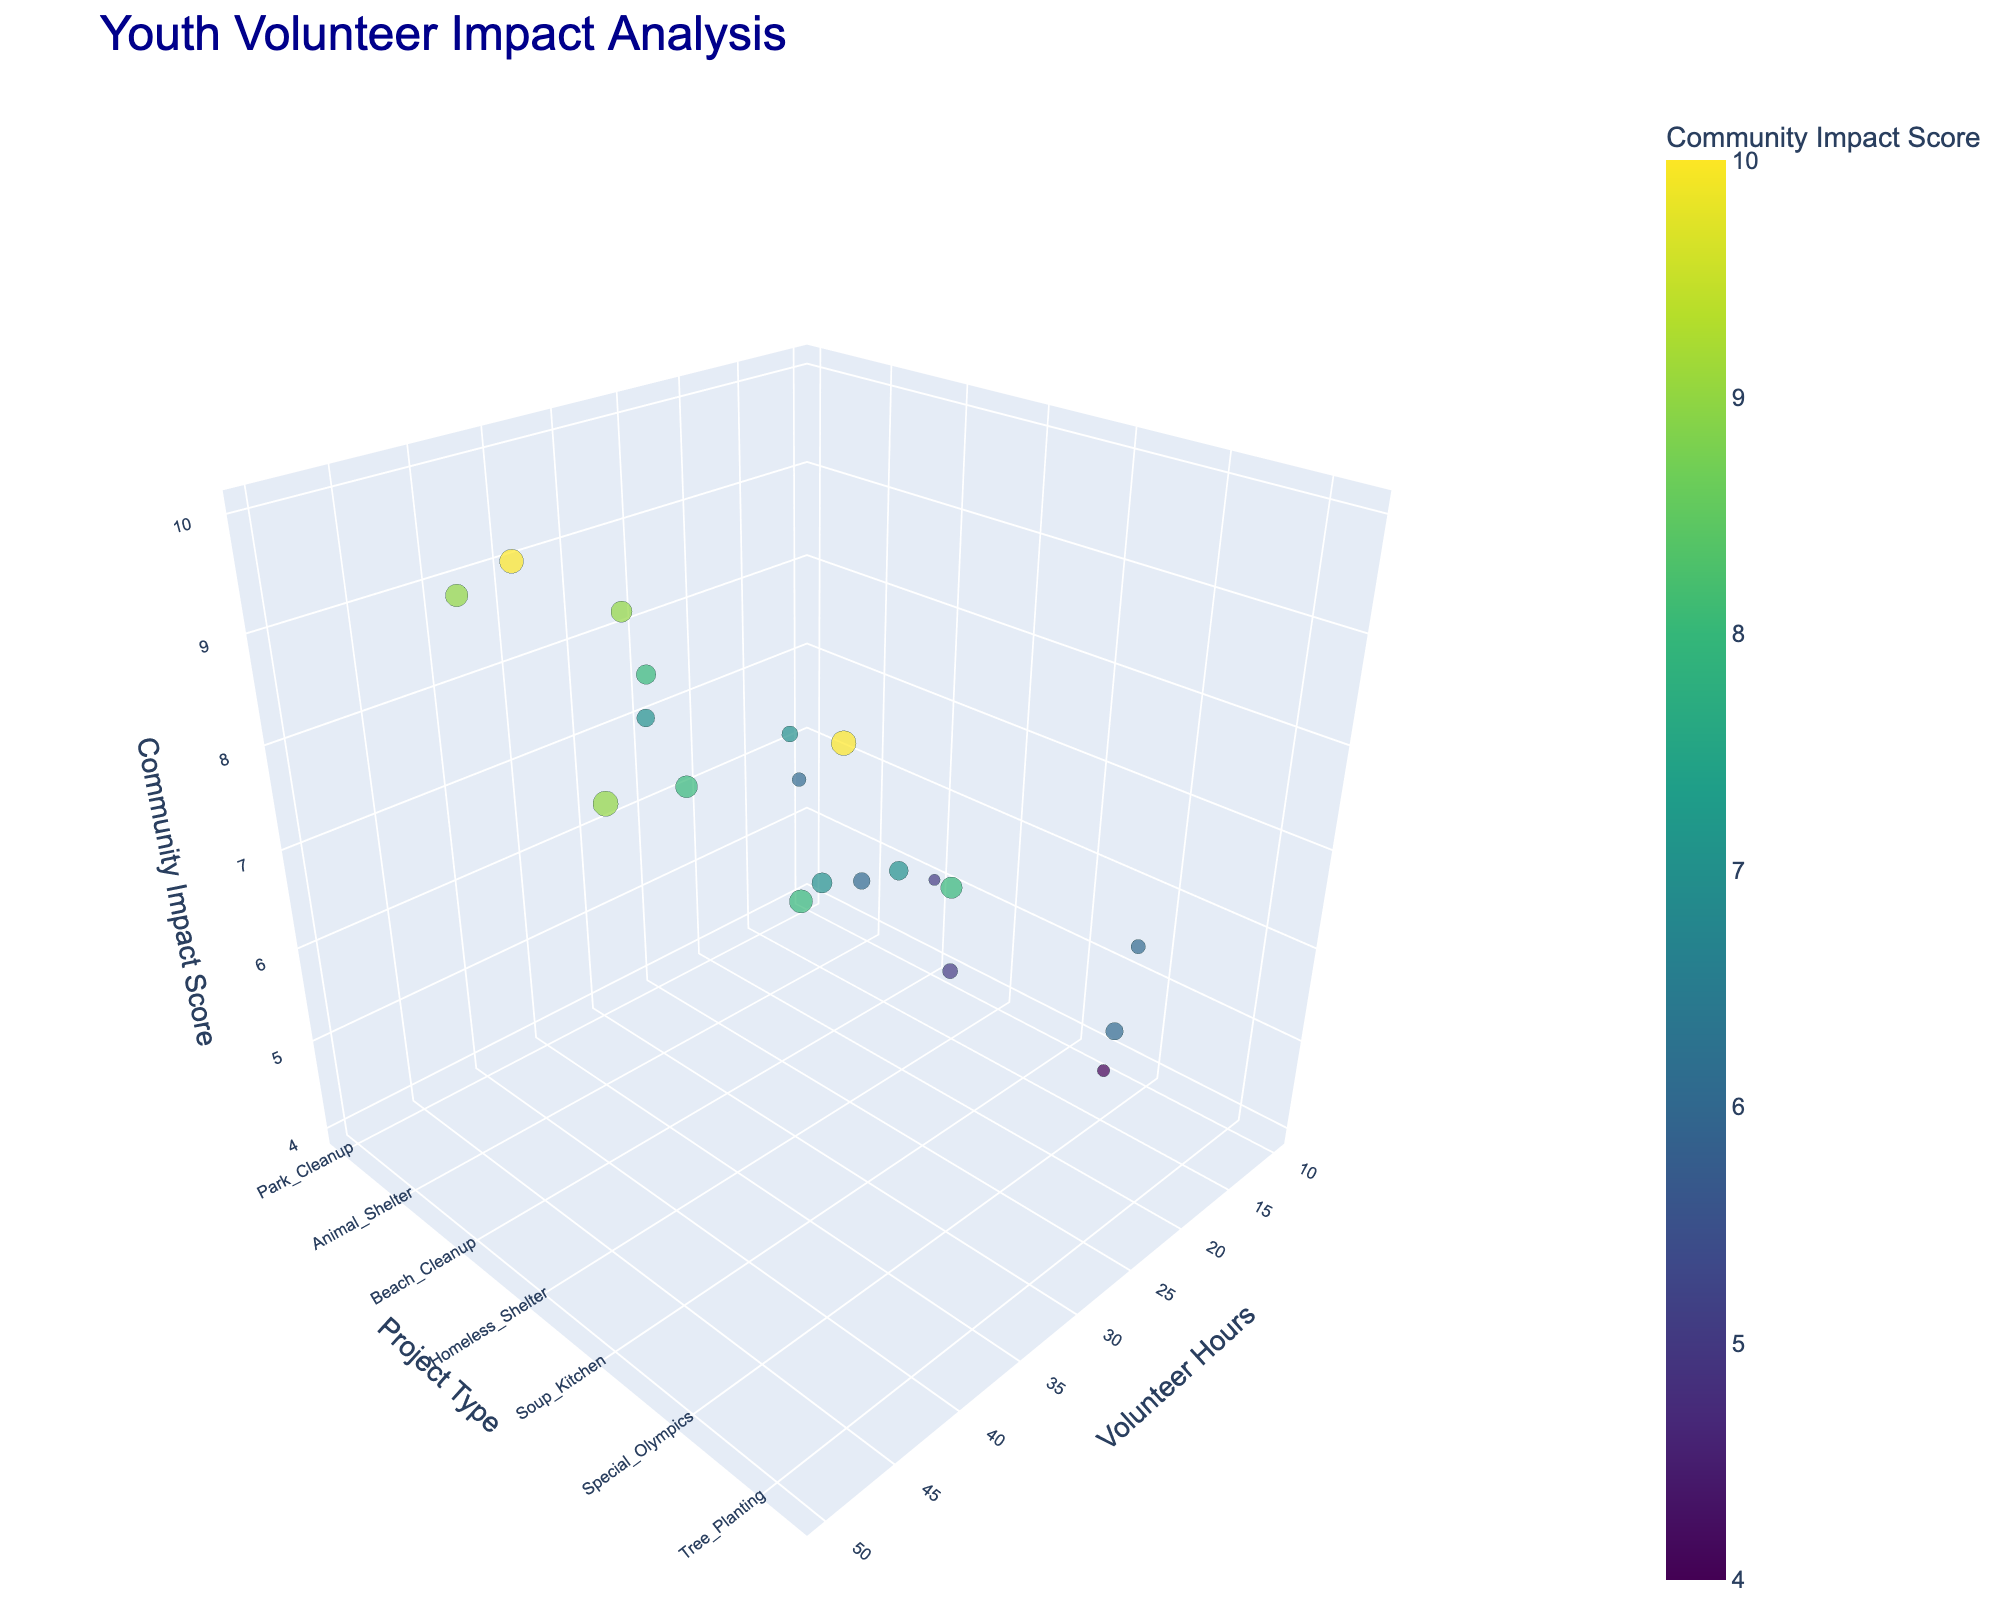what is the Project Type with the highest Community Impact Score? By looking at the scatter plot, we can see that the Project Type "Youth Mentoring" has a Community Impact Score of 10, which is the highest on the z-axis scale.
Answer: Youth Mentoring Which Project Type required the most Volunteer Hours? Referring to the x-axis of the scatter plot, the Project Type "Hospital Volunteer" used the most Volunteer Hours, which is 50.
Answer: Hospital Volunteer How many Project Types have a Community Impact Score of 8? By examining the points on the z-axis with a Community Impact Score of 8, we see that they are associated with 6 Project Types: Animal Shelter, Homeless Shelter, Special Olympics, Red Cross, Disaster Relief, and Habitat for Humanity.
Answer: 6 What is the relationship between Volunteer Hours and Community Impact Score for the Park Cleanup Project? The Park Cleanup Project has 25 Volunteer Hours and a Community Impact Score of 7. There is a direct correlation in this case, where increasing Volunteer Hours also matches an increase in Community Impact Score.
Answer: 25 hours and 7 score Compare the Community Impact Scores of Senior Care and Food Bank Projects. The Senior Care Project has a Community Impact Score of 9, while the Food Bank Project has a score of 6. Hence, the Community Impact Score of Senior Care is higher by 3 points.
Answer: Senior Care: 9, Food Bank: 6 What is the average Community Impact Score for Park Cleanup, Beach Cleanup, and Tree Planting Projects? First, note the Community Impact Scores: Park Cleanup (7), Beach Cleanup (5), and Tree Planting (6). Sum them: 7 + 5 + 6 = 18. There are 3 projects, so the average is 18/3.
Answer: 6 What is the difference in Volunteer Hours between the least and most demanded projects? The least Volunteer Hours are 10 (Beach Cleanup), and the most are 50 (Hospital Volunteer). The difference = 50 - 10.
Answer: 40 Identify the Project Type with the lowest Community Impact Score. Inspecting the scatter plot, the Project Type "Graffiti Removal" has the lowest Community Impact Score of 4.
Answer: Graffiti Removal Which Project Types have exactly 32 Volunteer Hours? From the scatter plot, the Project Type "After School Tutoring" is associated with exactly 32 Volunteer Hours.
Answer: After School Tutoring What is the range of Volunteer Hours in the data? Finding the minimum and maximum values of the x-axis (Volunteer Hours): Minimum is 10 (Beach Cleanup), and Maximum is 50 (Hospital Volunteer). The range is calculated as 50 - 10.
Answer: 40 